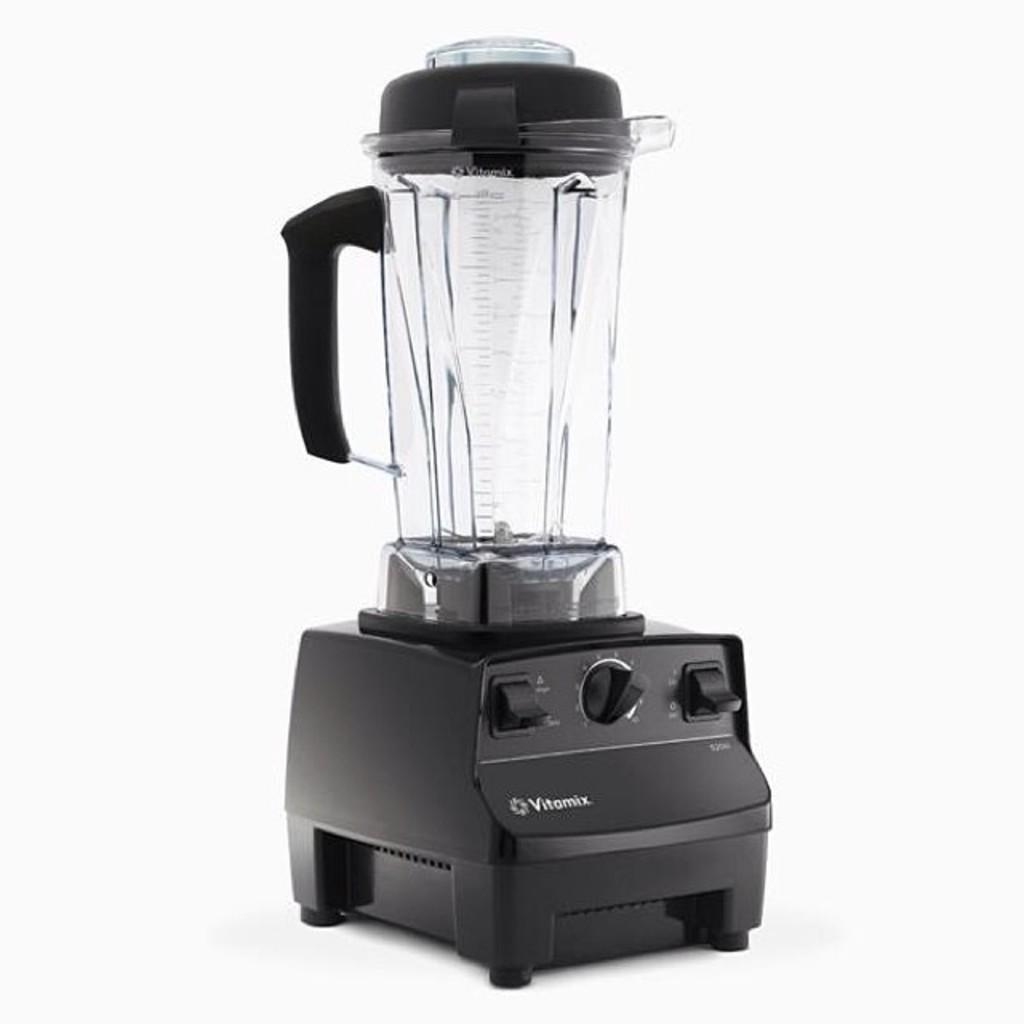Provide a one-sentence caption for the provided image. The Vitamix can make for an excellent blender. 